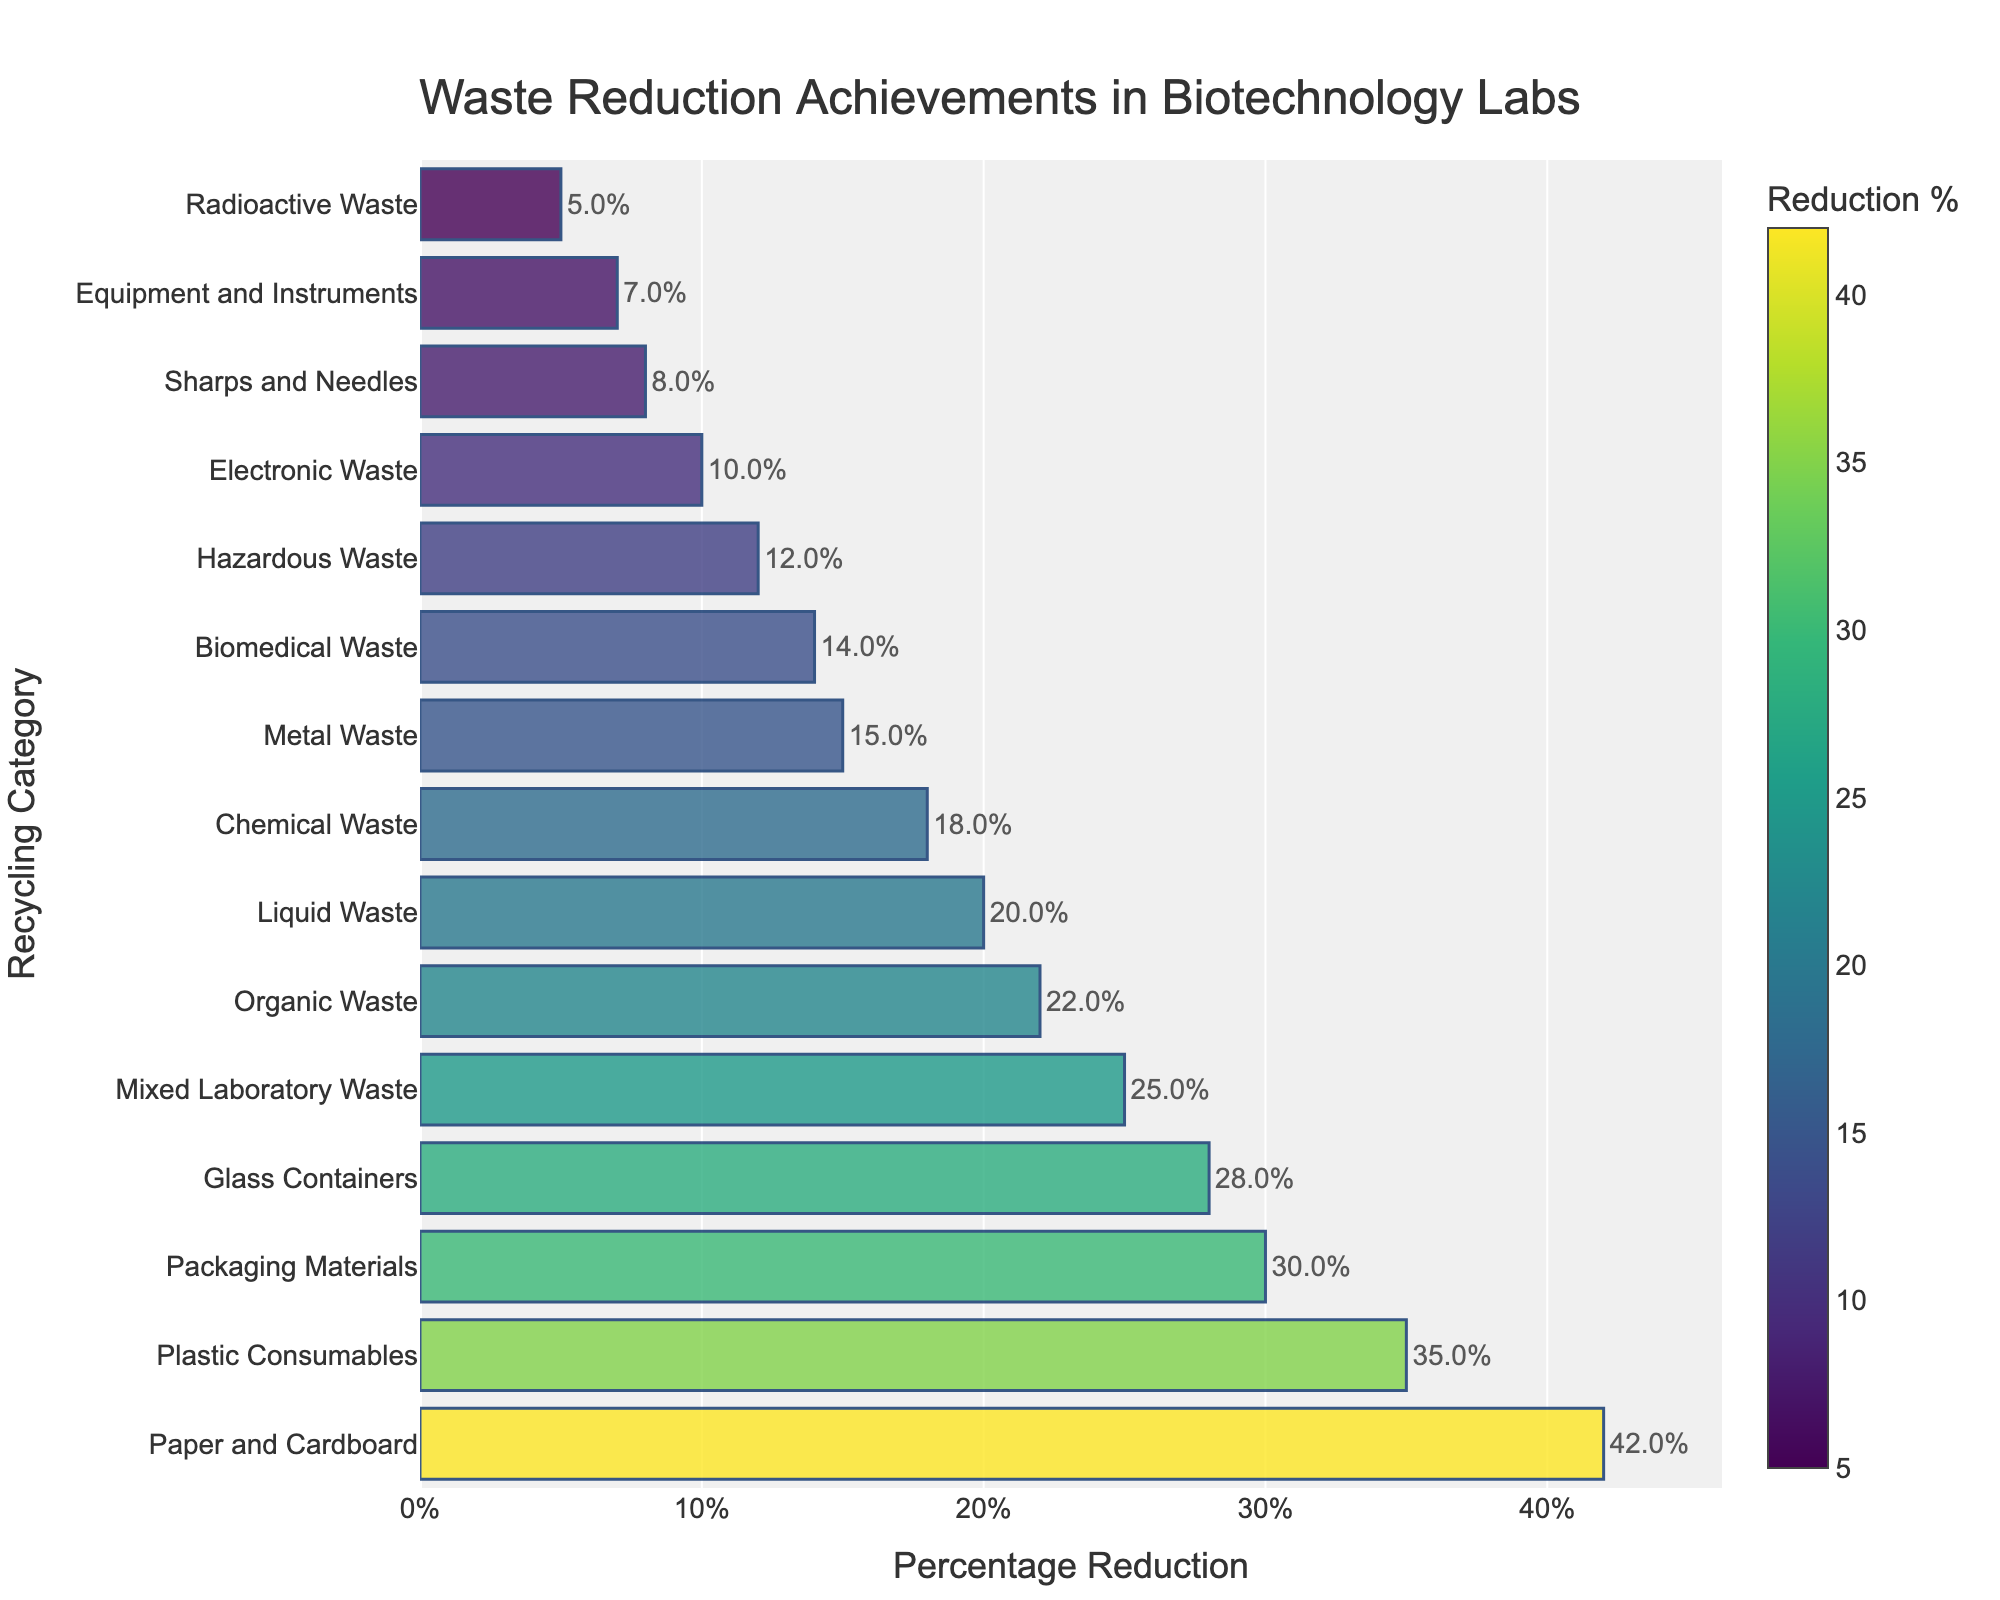What category has the highest percentage of waste reduction? To determine the category with the highest percentage of waste reduction, look for the longest bar in the plot. The bar with the highest value will correspond to the highest reduction percentage.
Answer: Paper and Cardboard Which category has the lowest percentage of waste reduction? To find the category with the lowest waste reduction, look for the shortest bar in the plot. The shortest bar will represent the lowest reduction percentage.
Answer: Radioactive Waste What is the combined percentage reduction of Plastic Consumables and Glass Containers? First, locate the bars for Plastic Consumables and Glass Containers on the plot and note their respective values (35% and 28%). Add these values together: 35% + 28% = 63%.
Answer: 63% How many categories have a waste reduction percentage of 20% or higher? Identify and count all the bars in the plot that have values equal to or greater than 20%. The categories meeting this criterion are Plastic Consumables (35%), Glass Containers (28%), Paper and Cardboard (42%), Organic Waste (22%), Mixed Laboratory Waste (25%), and Packaging Materials (30%). Thus, there are 6 categories.
Answer: 6 Which category has a reduction percentage closest to the median percentage reduction? To find the category closest to the median, first list all percentages and find the median: 5, 7, 8, 10, 12, 14, 15, 18, 20 (median), 22, 25, 28, 30, 35, 42. The median value is 20%. The category closest to the median is Liquid Waste, which also has a 20% reduction.
Answer: Liquid Waste How much higher is the waste reduction for Paper and Cardboard compared to Chemical Waste? Note the waste reduction percentages for Paper and Cardboard (42%) and Chemical Waste (18%). Subtract the smaller percentage from the larger one: 42% - 18% = 24%.
Answer: 24% Identify the category with a reduction percentage of 10% and discuss its bar's color relative to one with a 30% reduction. Locate the category with a 10% reduction (Electronic Waste) and the one with a 30% reduction (Packaging Materials). The bar for Electronic Waste will have a lighter color compared to the bar for Packaging Materials due to the color scale representing higher reductions with a darker color.
Answer: Electronic Waste's bar is lighter than Packaging Materials If you increase the percentage reductions of all categories by 5%, which category will have the highest new percentage reduction? First, increase all current percentages by 5%: The highest current value is Paper and Cardboard at 42%. Therefore, adding 5% results in 47%. Since Paper and Cardboard already had the highest value, it will remain the highest after the increase.
Answer: Paper and Cardboard What is the average percentage reduction of the top 5 categories? Identify the top 5 categories by the highest percentage reductions: Paper and Cardboard (42%), Plastic Consumables (35%), Packaging Materials (30%), Glass Containers (28%), Mixed Laboratory Waste (25%). Add these percentages and divide by 5: (42 + 35 + 30 + 28 + 25) / 5 = 160 / 5 = 32%.
Answer: 32% Which three categories are visually closest in color on the plot? Identify categories with percentage reductions that are numerically close, given the colors correspond to the reduction percentages: Glass Containers (28%), Mixed Laboratory Waste (25%), Packaging Materials (30%). These values are close to each other, resulting in similarly colored bars on the plot.
Answer: Glass Containers, Mixed Laboratory Waste, Packaging Materials 